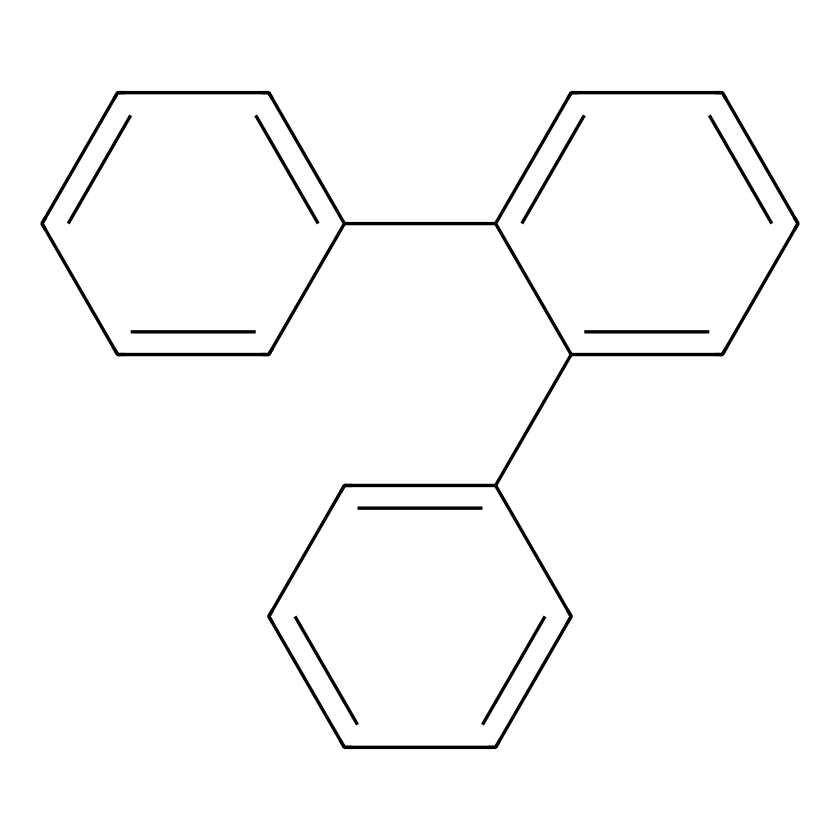What is the molecular formula of this compound? To find the molecular formula, we count the carbon and hydrogen atoms in the structure. Each benzene ring contributes six carbon atoms and six hydrogen atoms. With three fused benzene rings, the total is 18 carbon atoms and 12 hydrogen atoms, resulting in the formula C18H12.
Answer: C18H12 How many carbon atoms are there in the structure? Counting the carbon atoms in the structure reveals that there are 18 carbon atoms in total, as this structure consists of three benzene rings.
Answer: 18 What type of hybridization do the carbon atoms in this compound exhibit? Carbon atoms in benzene are sp2 hybridized due to the presence of one double bond in each carbon's bonding configuration, which allows for the planar structure and delocalized electrons.
Answer: sp2 How many rings does this compound contain? The structure showcases three interconnected benzene rings. Each individual ring counts towards the total. Thus, the answer is three.
Answer: 3 What type of hydrocarbons does this compound belong to? The structure is comprised of benzene rings, which classifies it as an aromatic hydrocarbon due to the presence of stable resonance within the rings.
Answer: aromatic 